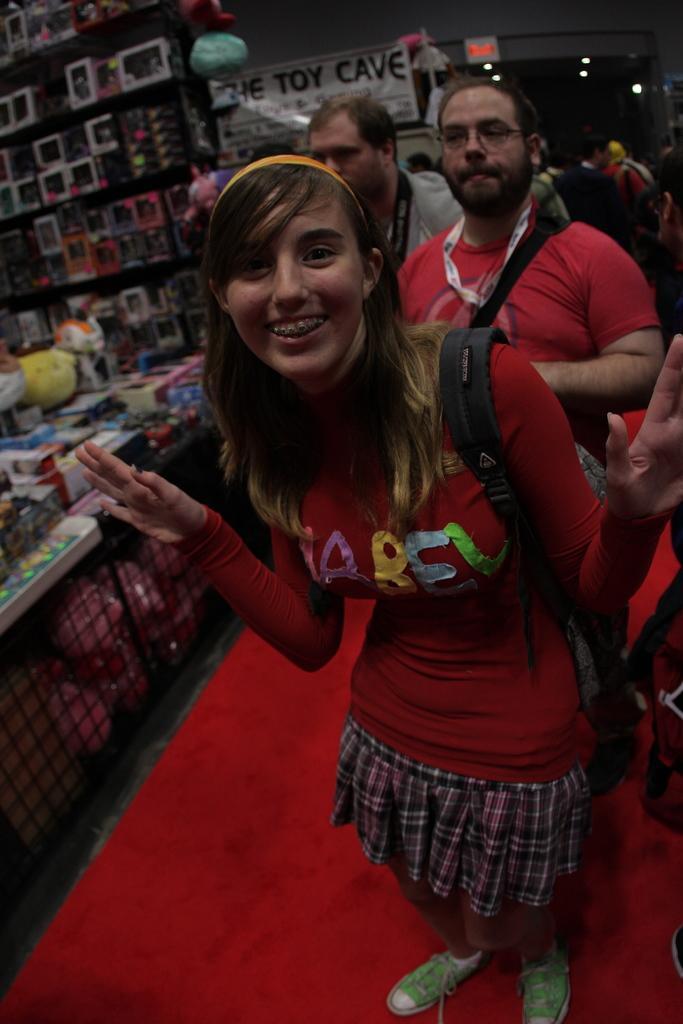In one or two sentences, can you explain what this image depicts? In the background we can see a board, banner and lights. On the left side of the picture we can see objects in the racks. In this picture we can see toys, grille and objects. We can see the people. We can see a woman wearing a backpack, she is standing and smiling. 